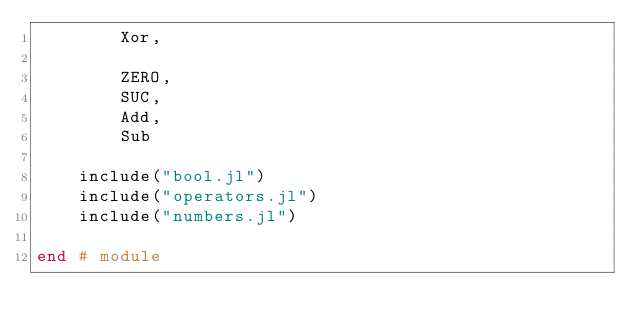Convert code to text. <code><loc_0><loc_0><loc_500><loc_500><_Julia_>        Xor,

        ZERO,
        SUC,
        Add,
        Sub

    include("bool.jl")
    include("operators.jl")
    include("numbers.jl")

end # module
</code> 